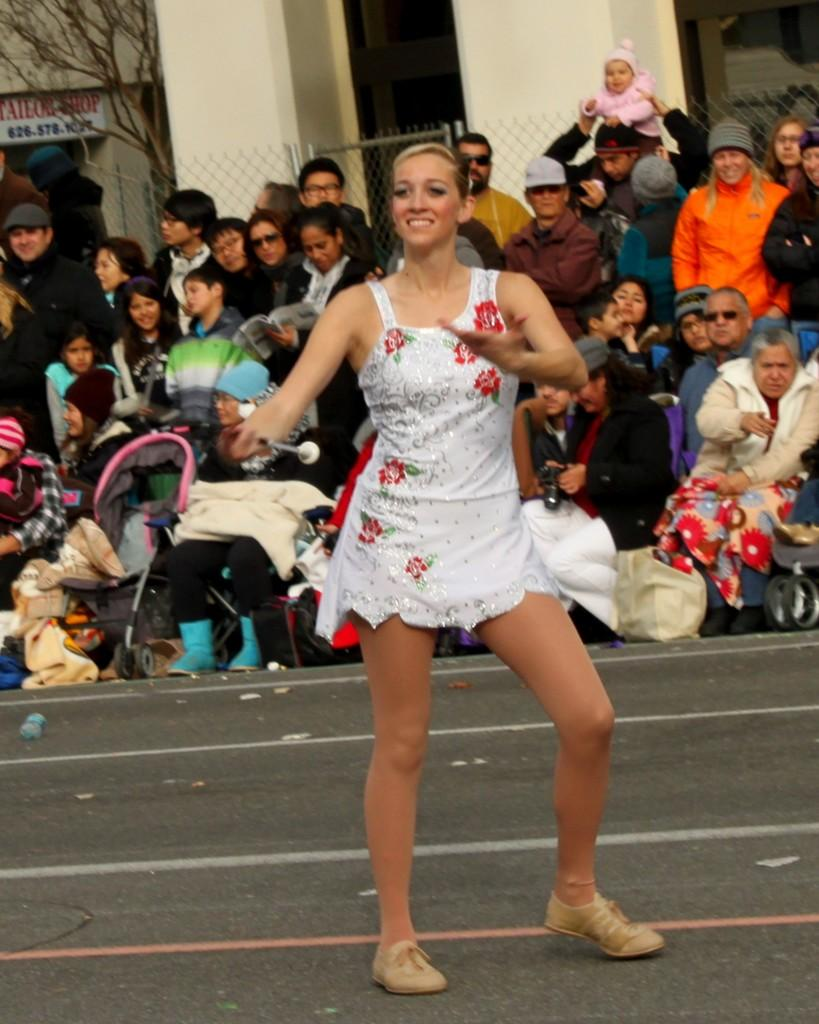What is the girl in the image doing? The girl is dancing in the image. Where is the girl dancing? The girl is on the road. Are there any people watching the girl dance? Yes, there are spectators behind the girl. What can be seen in the background of the image? There are buildings and a tree in the background of the image. What type of brush is being used by the girl while dancing in the image? There is no brush present in the image; the girl is dancing without any visible props or tools. 